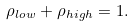Convert formula to latex. <formula><loc_0><loc_0><loc_500><loc_500>\rho _ { l o w } + \rho _ { h i g h } = 1 .</formula> 